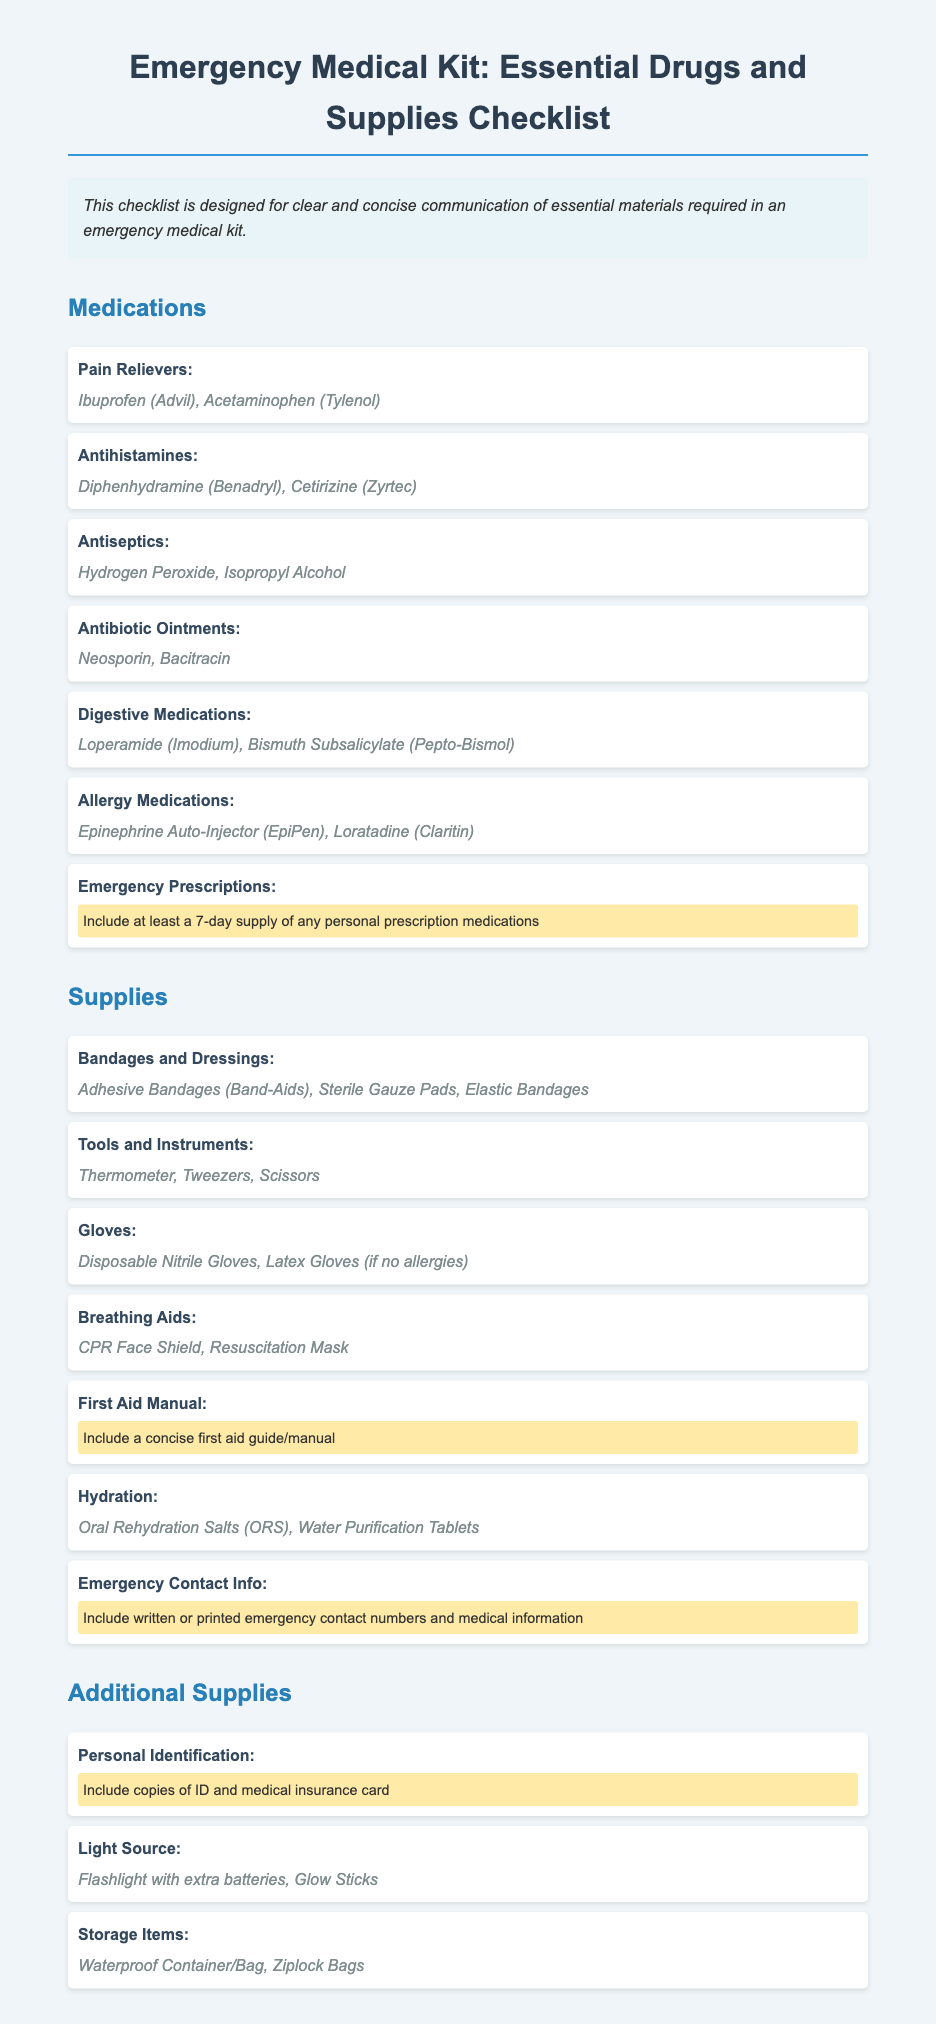what are two examples of pain relievers? The document lists Ibuprofen (Advil) and Acetaminophen (Tylenol) as examples of pain relievers.
Answer: Ibuprofen, Acetaminophen what type of gloves are recommended? The document specifies Disposable Nitrile Gloves and Latex Gloves (if no allergies) as the recommended types.
Answer: Disposable Nitrile Gloves, Latex Gloves how many days of emergency prescriptions should be included? The document advises including at least a 7-day supply of personal prescription medications.
Answer: 7-day what items fall under emergency contact information? The document mentions including written or printed emergency contact numbers and medical information.
Answer: Contact numbers, medical information what is a required hydration supply? The document suggests Oral Rehydration Salts (ORS) or Water Purification Tablets as necessary hydration supplies.
Answer: Oral Rehydration Salts, Water Purification Tablets how should first aid information be included? The document states to include a concise first aid guide/manual as part of the supplies.
Answer: First aid guide/manual what is included in personal identification? The document mentions including copies of ID and medical insurance card as part of personal identification.
Answer: ID, medical insurance card what kind of medication should be in the allergy section? The document lists Epinephrine Auto-Injector (EpiPen) and Loratadine (Claritin) for allergy medications.
Answer: EpiPen, Loratadine what is a key tool mentioned for emergencies? The document identifies a Thermometer as one of the key tools necessary for emergencies.
Answer: Thermometer 